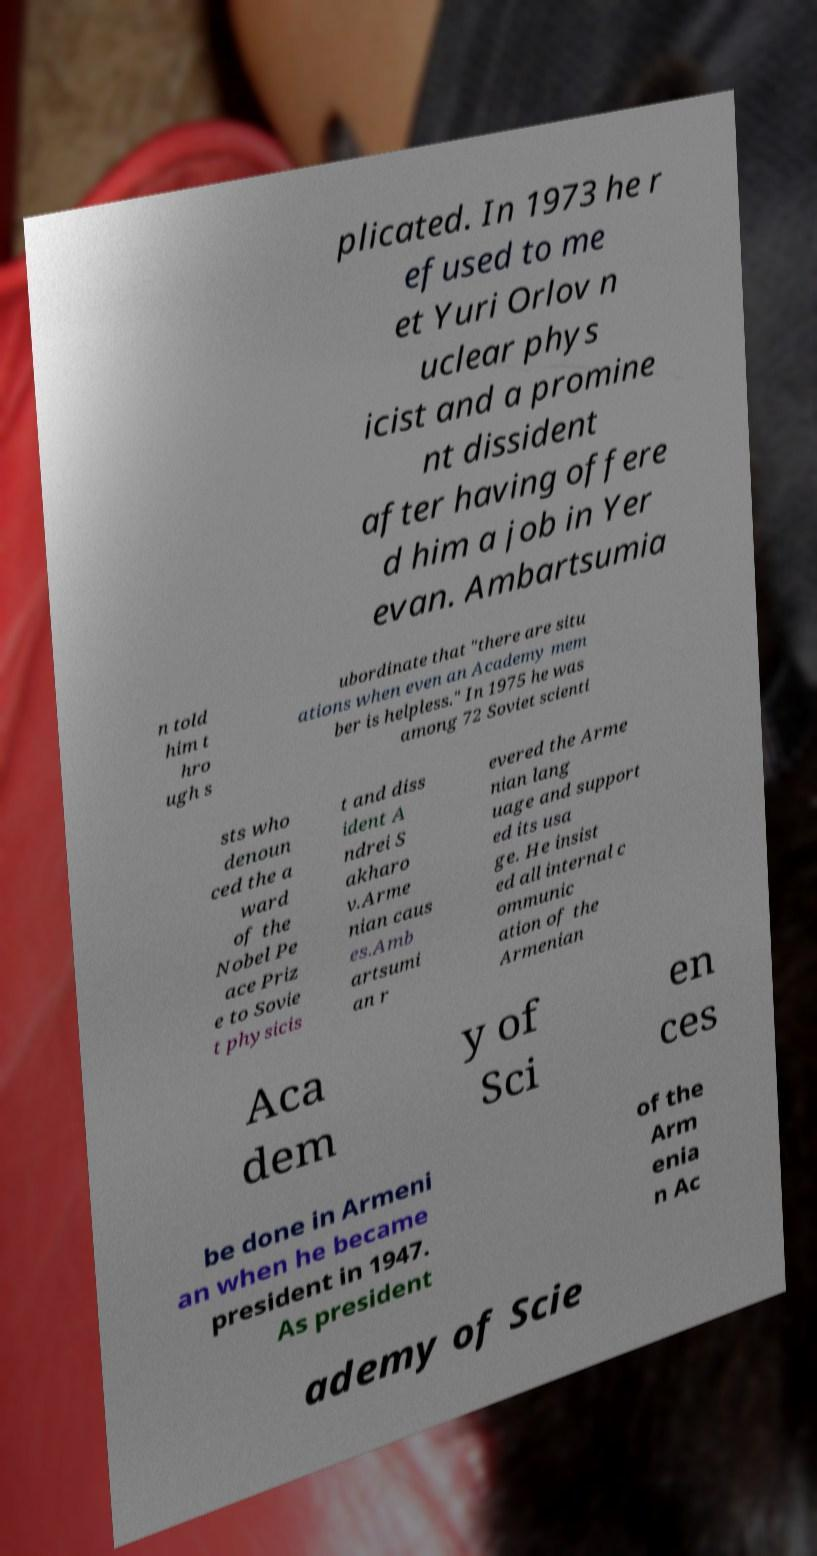For documentation purposes, I need the text within this image transcribed. Could you provide that? plicated. In 1973 he r efused to me et Yuri Orlov n uclear phys icist and a promine nt dissident after having offere d him a job in Yer evan. Ambartsumia n told him t hro ugh s ubordinate that "there are situ ations when even an Academy mem ber is helpless." In 1975 he was among 72 Soviet scienti sts who denoun ced the a ward of the Nobel Pe ace Priz e to Sovie t physicis t and diss ident A ndrei S akharo v.Arme nian caus es.Amb artsumi an r evered the Arme nian lang uage and support ed its usa ge. He insist ed all internal c ommunic ation of the Armenian Aca dem y of Sci en ces be done in Armeni an when he became president in 1947. As president of the Arm enia n Ac ademy of Scie 